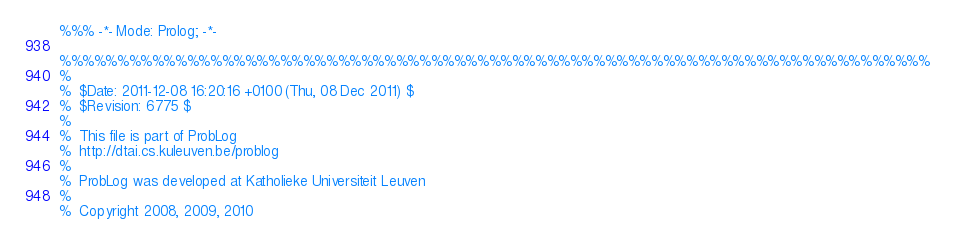<code> <loc_0><loc_0><loc_500><loc_500><_Prolog_>%%% -*- Mode: Prolog; -*-

%%%%%%%%%%%%%%%%%%%%%%%%%%%%%%%%%%%%%%%%%%%%%%%%%%%%%%%%%%%%%%%%%%%%%%%%%%%
%
%  $Date: 2011-12-08 16:20:16 +0100 (Thu, 08 Dec 2011) $
%  $Revision: 6775 $
%
%  This file is part of ProbLog
%  http://dtai.cs.kuleuven.be/problog
%
%  ProbLog was developed at Katholieke Universiteit Leuven
%
%  Copyright 2008, 2009, 2010</code> 